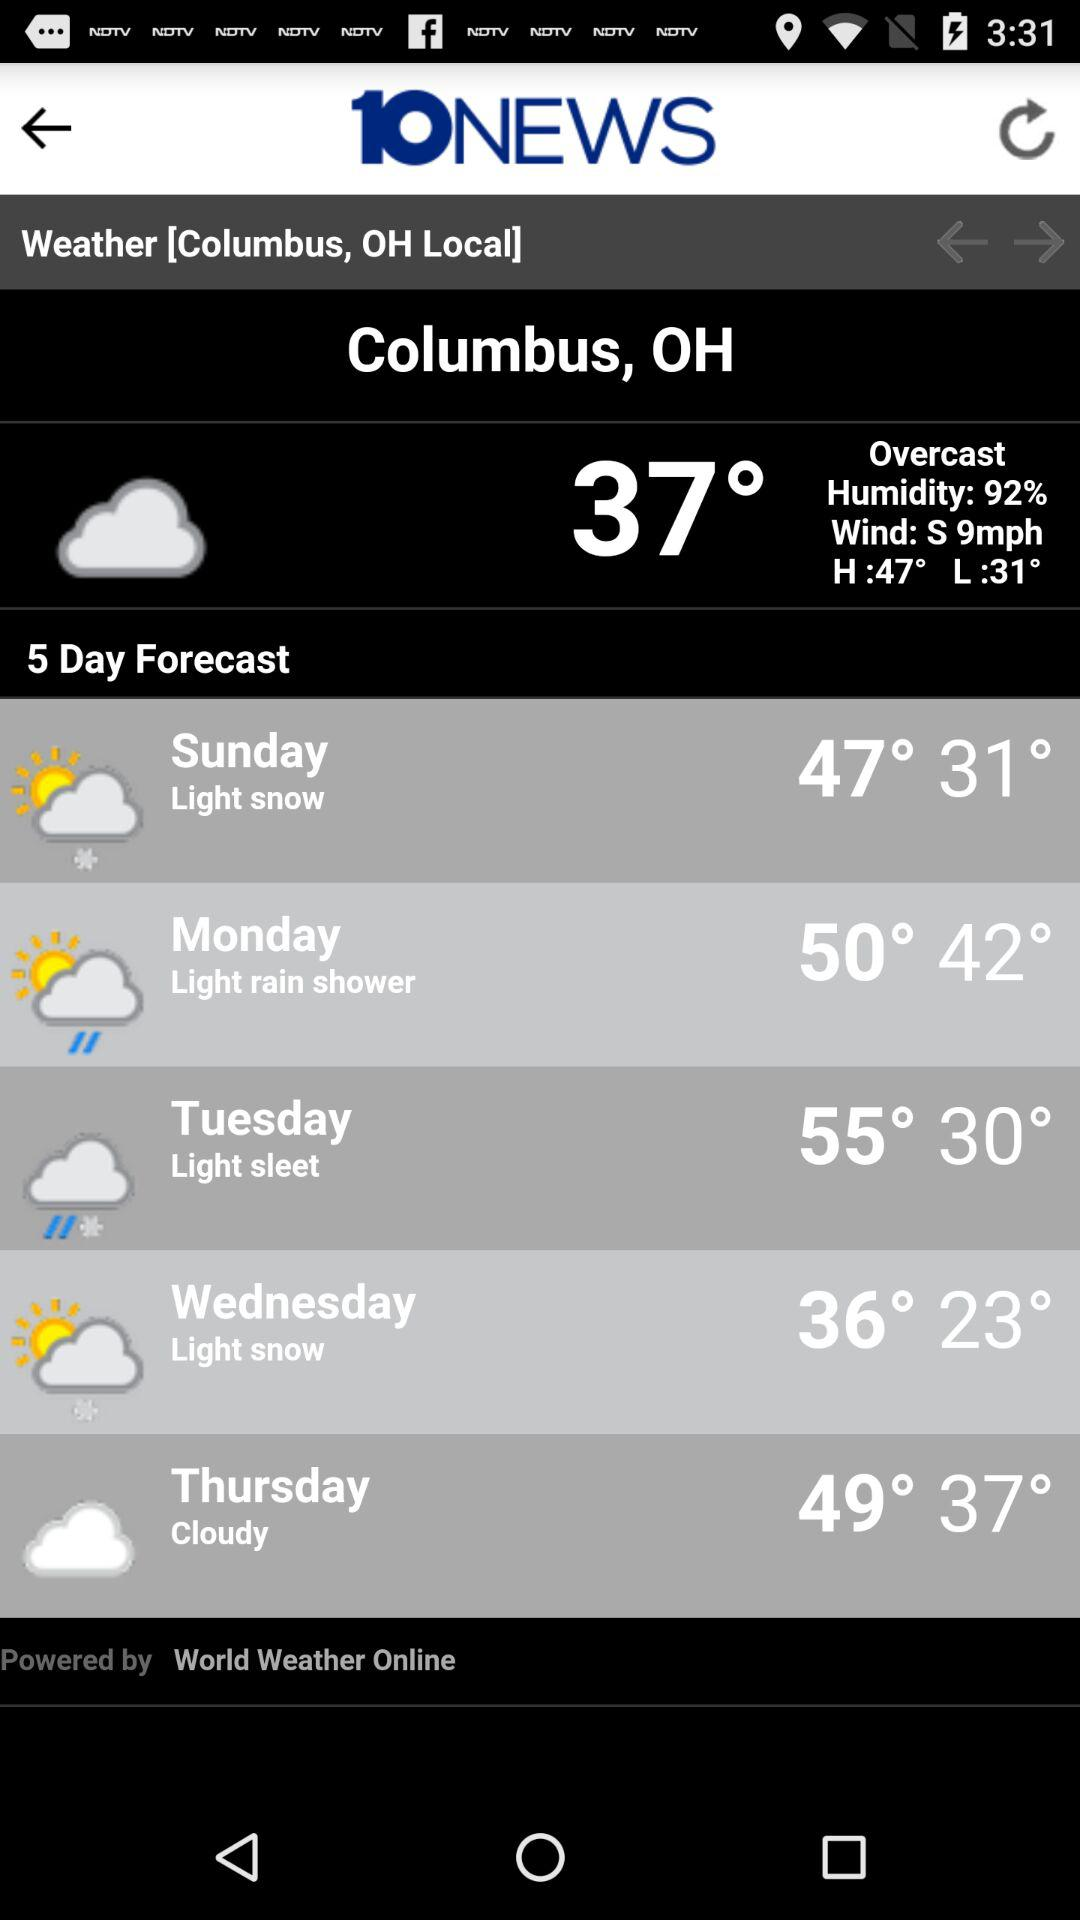How many days are there in the forecast?
Answer the question using a single word or phrase. 5 